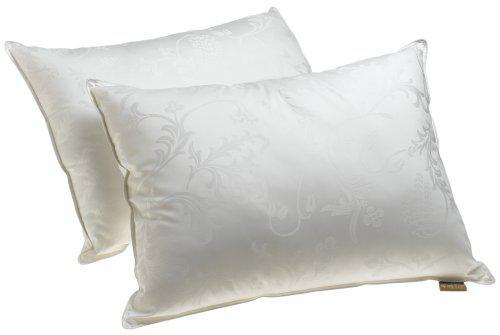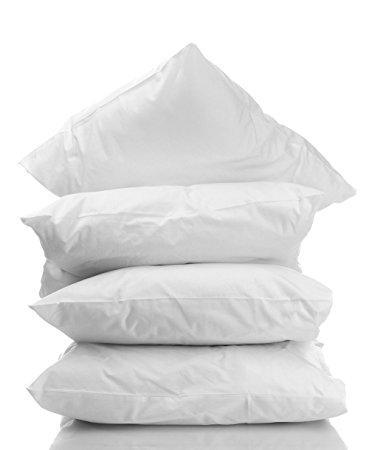The first image is the image on the left, the second image is the image on the right. For the images displayed, is the sentence "There are four pillows stacked up in the image on the left." factually correct? Answer yes or no. No. 